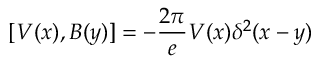Convert formula to latex. <formula><loc_0><loc_0><loc_500><loc_500>[ V ( x ) , B ( y ) ] = - { \frac { 2 \pi } { e } } V ( x ) \delta ^ { 2 } ( x - y )</formula> 